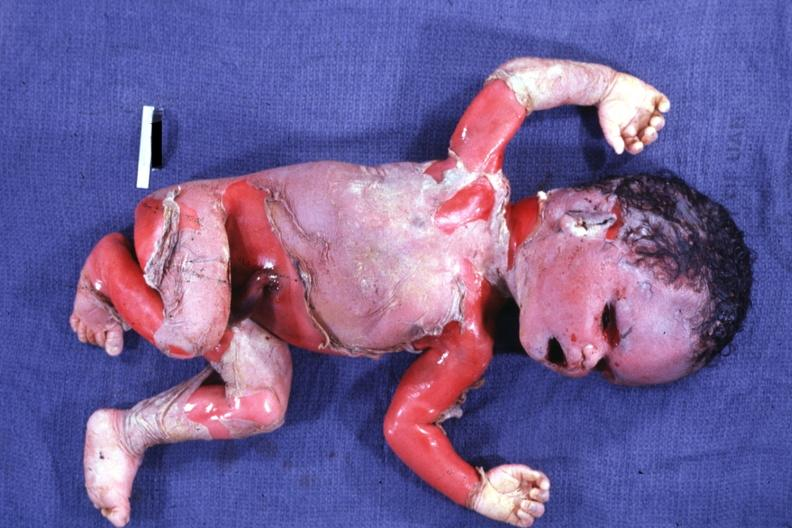does acid show severe maceration?
Answer the question using a single word or phrase. No 